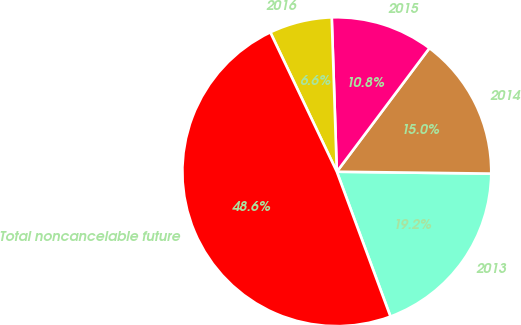<chart> <loc_0><loc_0><loc_500><loc_500><pie_chart><fcel>2013<fcel>2014<fcel>2015<fcel>2016<fcel>Total noncancelable future<nl><fcel>19.16%<fcel>14.96%<fcel>10.76%<fcel>6.56%<fcel>48.56%<nl></chart> 